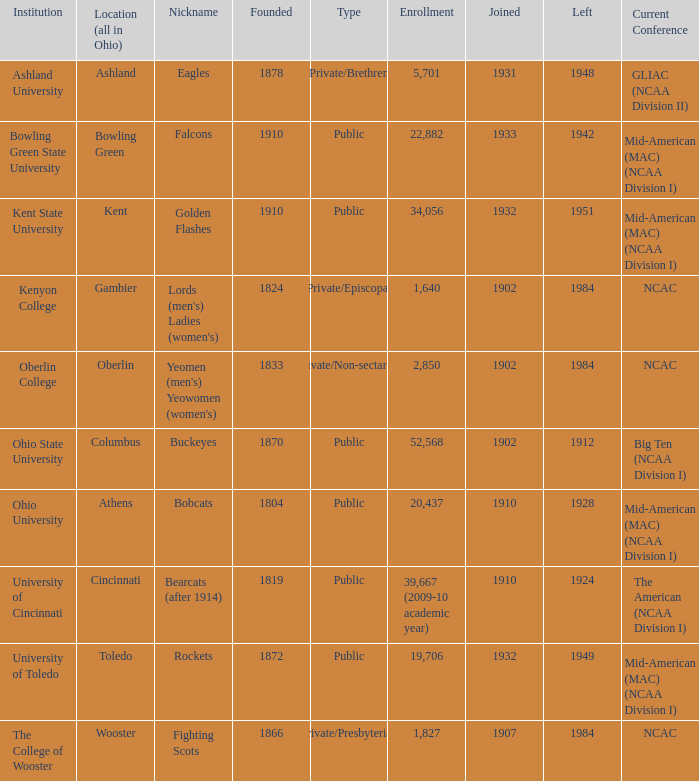In what year did registered gambier members depart? 1984.0. 